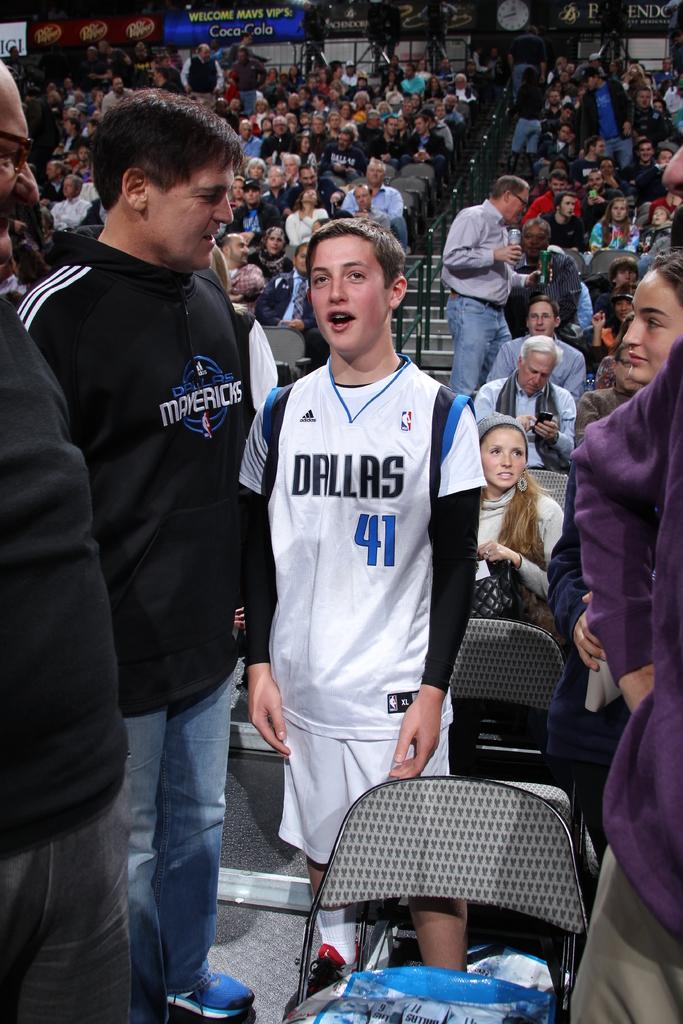What jersey is he wearing?
Keep it short and to the point. Dallas. What is the team name of the black jacket?
Give a very brief answer. Mavericks. 